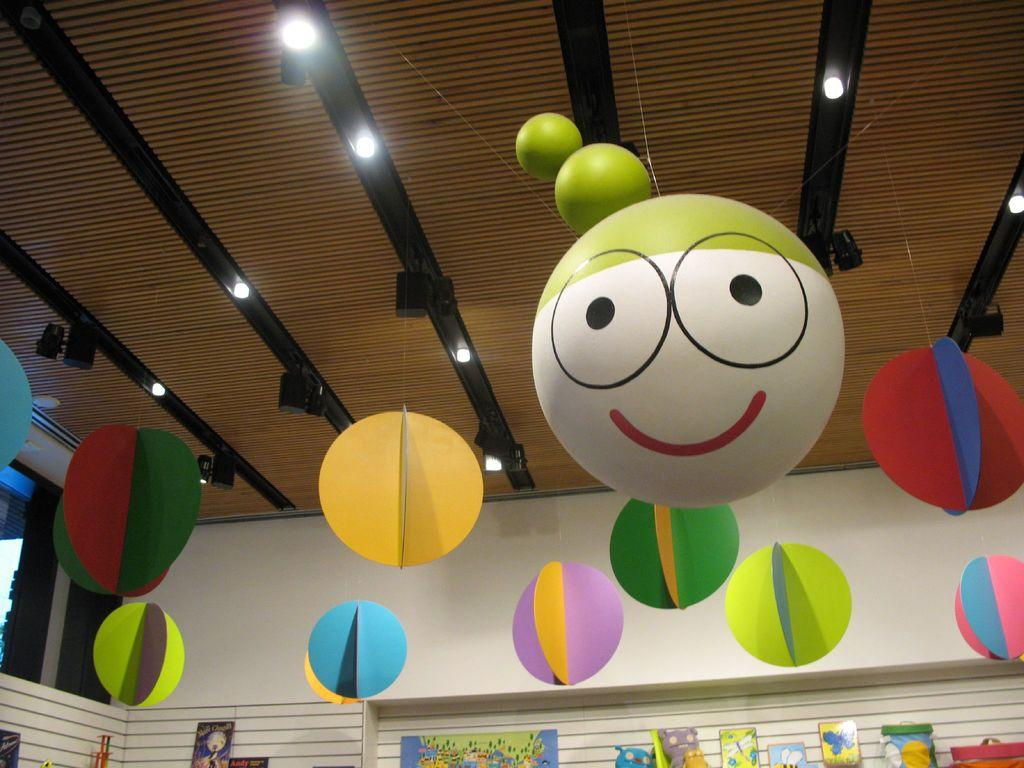What is the color of the wall in the image? The wall in the image is white. What objects can be seen on the wall? There are balls and photo frames on the wall in the image. Is there any opening in the wall? Yes, there is a window in the image. Where is the mailbox located in the image? There is no mailbox present in the image. What type of scale can be seen in the image? There is no scale present in the image. 